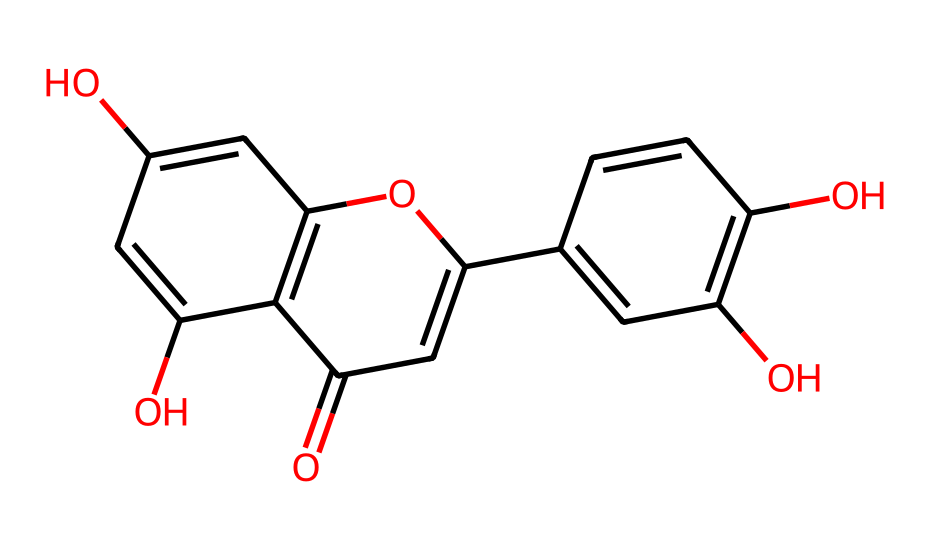What is the molecular formula of this dye? To determine the molecular formula, count the number of each type of atom present in the SMILES representation. This molecule has 21 carbons, 18 hydrogens, and 9 oxygens, leading to the formula C21H18O9.
Answer: C21H18O9 How many rings are in this chemical structure? Examine the SMILES structure, identifying the components within the parentheses and the repeating units. This structure contains three connected rings.
Answer: three What functional groups are present in this dye? Analyze the SMILES to identify specific arrangements of atoms that denote functional groups. The presence of hydroxyl (-OH) groups suggests that this dye possesses phenolic and carbonyl functionalities.
Answer: hydroxyl and carbonyl What type of dye is represented by this chemical structure? Consider the overall structure, particularly the presence of multiple phenolic groups and a planar arrangement conducive to the absorption of visible light. This dye is classified as a natural dye.
Answer: natural dye Is this dye likely to be water-soluble? Look at the presence of hydroxyl groups, which typically increase solubility in water due to their ability to form hydrogen bonds. The multiple -OH groups indicate a higher likelihood of water solubility.
Answer: likely What color might this dye produce when used in a religious ceremony? Evaluate the structure's features, especially conjugated double bonds and substituents, which can indicate the color produced when this dye is applied. The structure suggests that it may produce red or purple hues.
Answer: red or purple 